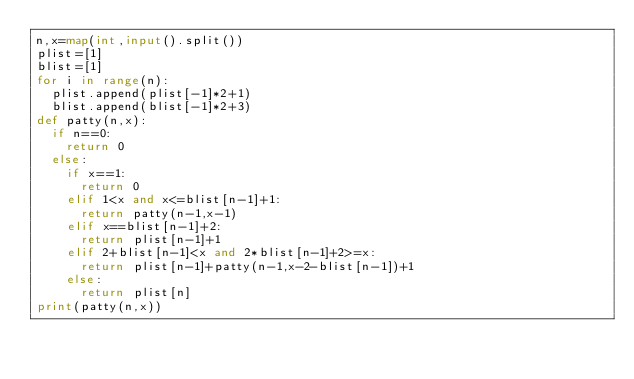<code> <loc_0><loc_0><loc_500><loc_500><_Python_>n,x=map(int,input().split())
plist=[1]
blist=[1]
for i in range(n):
  plist.append(plist[-1]*2+1)
  blist.append(blist[-1]*2+3)
def patty(n,x):
  if n==0:
    return 0
  else:
    if x==1:
      return 0
    elif 1<x and x<=blist[n-1]+1:
      return patty(n-1,x-1)
    elif x==blist[n-1]+2:
      return plist[n-1]+1
    elif 2+blist[n-1]<x and 2*blist[n-1]+2>=x:
      return plist[n-1]+patty(n-1,x-2-blist[n-1])+1
    else:
      return plist[n]
print(patty(n,x))
</code> 